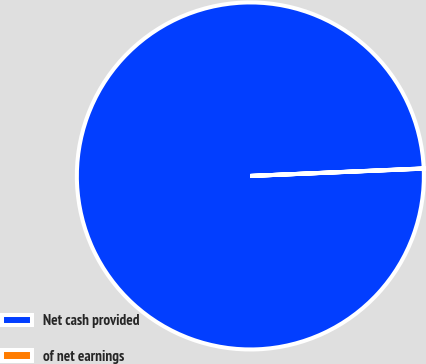Convert chart. <chart><loc_0><loc_0><loc_500><loc_500><pie_chart><fcel>Net cash provided<fcel>of net earnings<nl><fcel>99.98%<fcel>0.02%<nl></chart> 